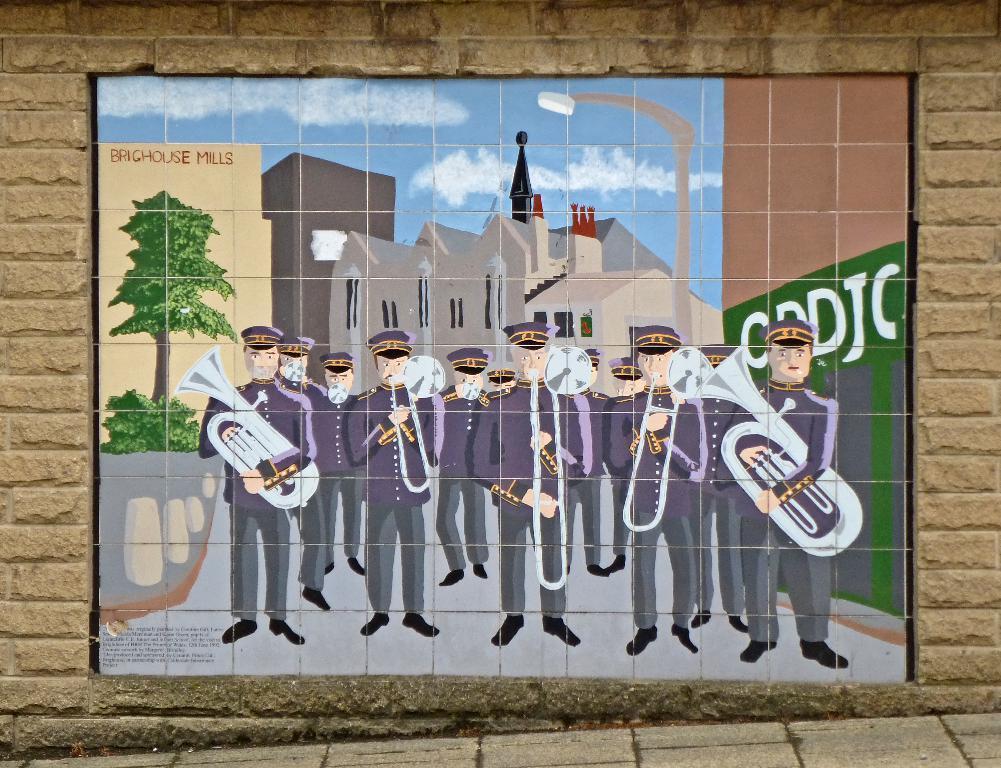Please provide a concise description of this image. In this picture we can see a board on the wall, here we can see a group of people standing on the ground and we can see musical instruments, buildings, trees and the sky. 